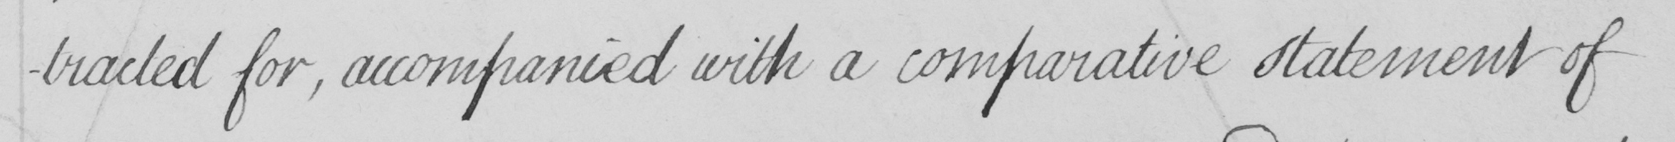Can you tell me what this handwritten text says? -tracted for , accompanied with a comparative statement of 